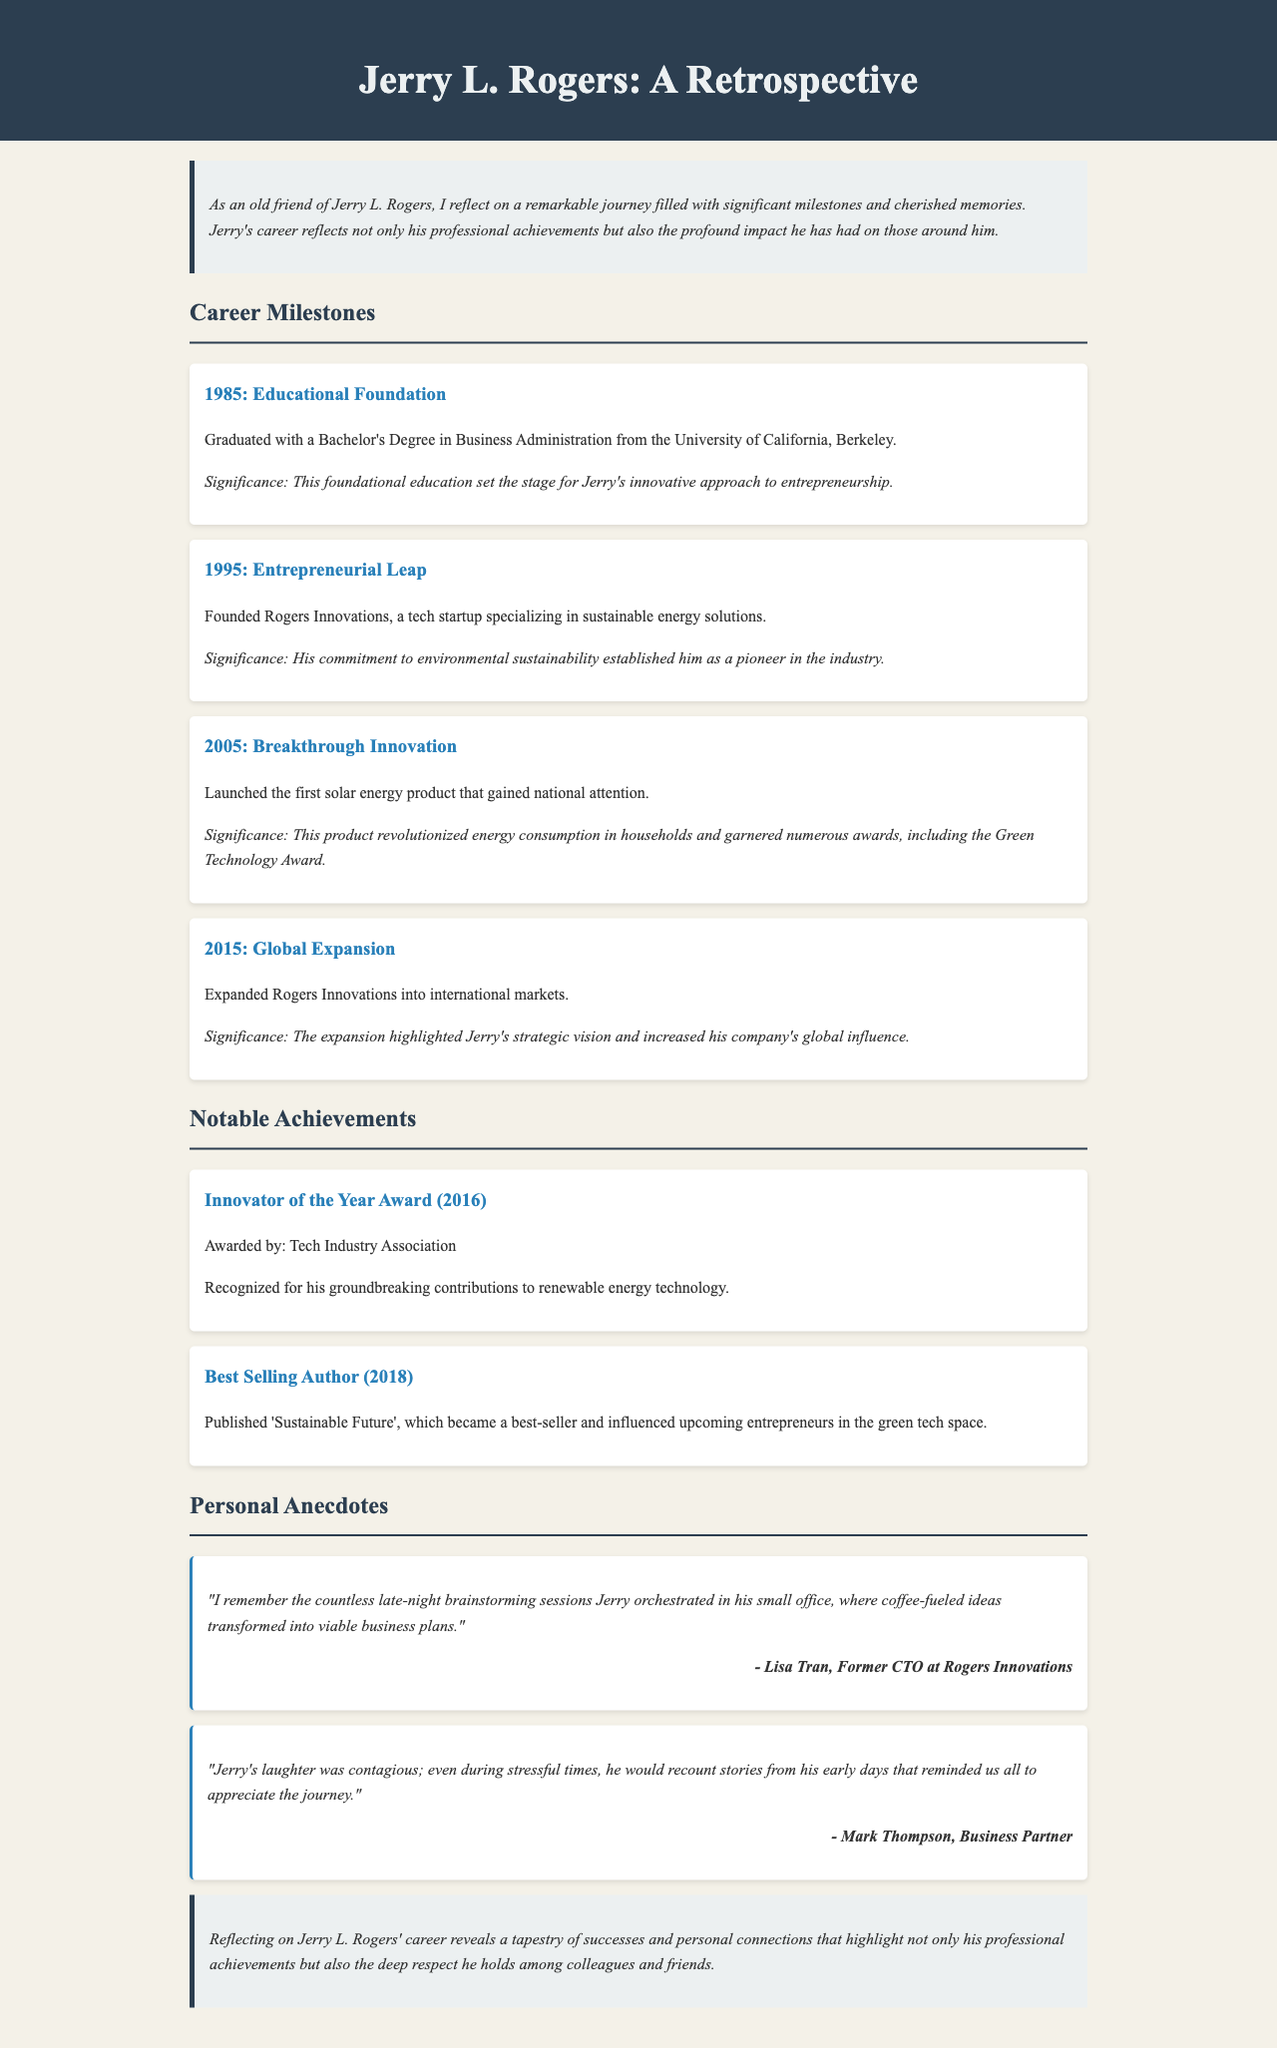what degree did Jerry L. Rogers earn in 1985? The document states that he graduated with a Bachelor's Degree in Business Administration in 1985.
Answer: Bachelor's Degree in Business Administration what was the name of Jerry's tech startup founded in 1995? The document mentions that he founded Rogers Innovations in 1995.
Answer: Rogers Innovations which award did Jerry L. Rogers receive in 2016? The document specifies that he was awarded the Innovator of the Year Award in 2016.
Answer: Innovator of the Year Award how many personal anecdotes are mentioned in the document? The document contains two personal anecdotes shared by colleagues.
Answer: Two what was the significance of Jerry's solar energy product launched in 2005? The document explains that the product revolutionized energy consumption in households and garnered numerous awards.
Answer: Revolutionized energy consumption who described working late nights with Jerry in an anecdote? The document attributes the anecdote about late-night brainstorming sessions to Lisa Tran.
Answer: Lisa Tran what theme is emphasized in the conclusion of the document? The conclusion highlights the theme of respect among colleagues and friends regarding Jerry's career.
Answer: Respect among colleagues and friends 